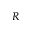<formula> <loc_0><loc_0><loc_500><loc_500>R</formula> 